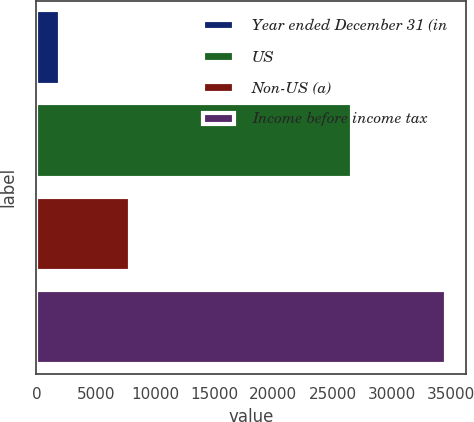Convert chart. <chart><loc_0><loc_0><loc_500><loc_500><bar_chart><fcel>Year ended December 31 (in<fcel>US<fcel>Non-US (a)<fcel>Income before income tax<nl><fcel>2016<fcel>26651<fcel>7885<fcel>34536<nl></chart> 